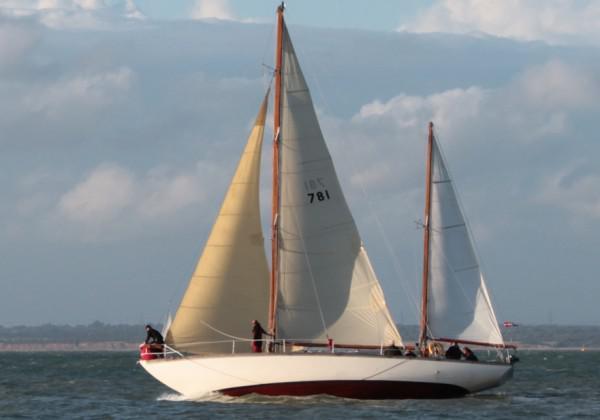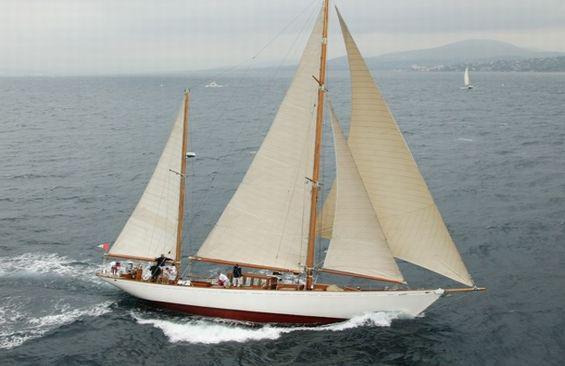The first image is the image on the left, the second image is the image on the right. For the images displayed, is the sentence "There is a landform visible behind the boat in one of the images." factually correct? Answer yes or no. No. The first image is the image on the left, the second image is the image on the right. Analyze the images presented: Is the assertion "One image shows a boat with exactly three sails." valid? Answer yes or no. Yes. 